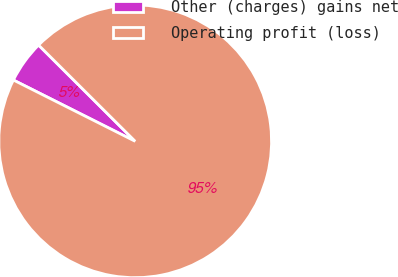Convert chart. <chart><loc_0><loc_0><loc_500><loc_500><pie_chart><fcel>Other (charges) gains net<fcel>Operating profit (loss)<nl><fcel>5.05%<fcel>94.95%<nl></chart> 